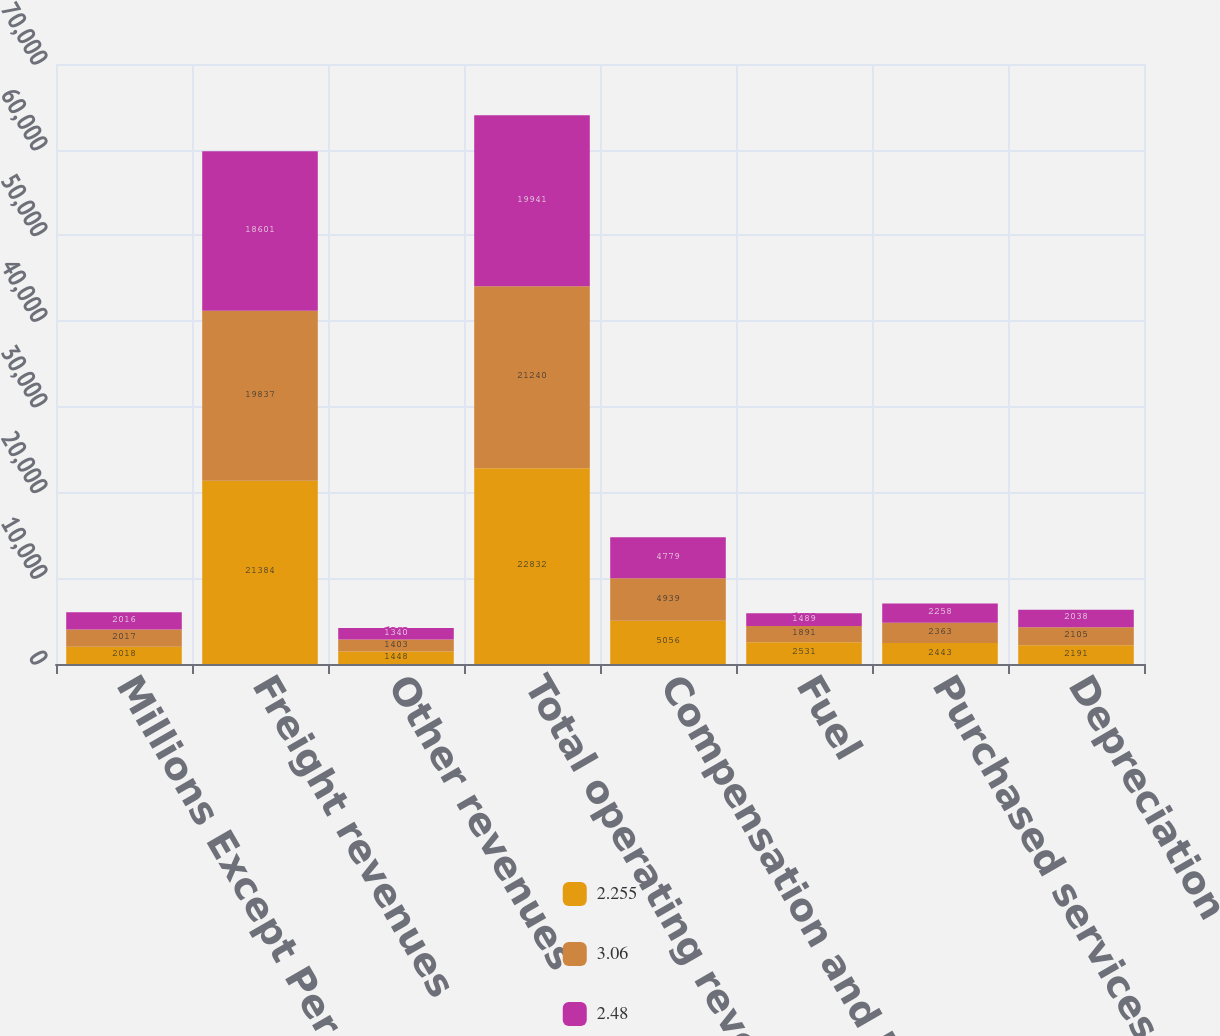Convert chart. <chart><loc_0><loc_0><loc_500><loc_500><stacked_bar_chart><ecel><fcel>Millions Except Per Share<fcel>Freight revenues<fcel>Other revenues<fcel>Total operating revenues<fcel>Compensation and benefits<fcel>Fuel<fcel>Purchased services and<fcel>Depreciation<nl><fcel>2.255<fcel>2018<fcel>21384<fcel>1448<fcel>22832<fcel>5056<fcel>2531<fcel>2443<fcel>2191<nl><fcel>3.06<fcel>2017<fcel>19837<fcel>1403<fcel>21240<fcel>4939<fcel>1891<fcel>2363<fcel>2105<nl><fcel>2.48<fcel>2016<fcel>18601<fcel>1340<fcel>19941<fcel>4779<fcel>1489<fcel>2258<fcel>2038<nl></chart> 